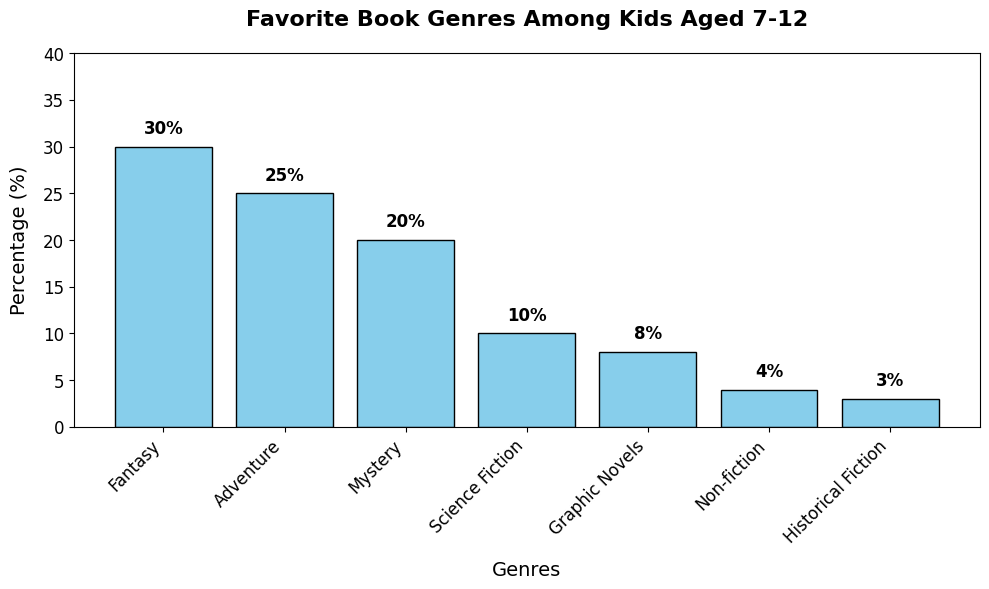What's the most popular book genre among kids aged 7-12? The tallest bar represents the most popular book genre. In the figure, the tallest bar is labeled "Fantasy".
Answer: Fantasy Which genre has a higher percentage, Adventure or Mystery? By comparing the heights of the bars for Adventure and Mystery, you can see that Adventure is taller. The percentages listed show Adventure at 25% and Mystery at 20%.
Answer: Adventure What is the combined percentage of kids who prefer Fantasy and Adventure genres? First, find the percentages for Fantasy (30%) and Adventure (25%). Then, add them together: 30% + 25% = 55%.
Answer: 55% How much more popular is Science Fiction compared to Non-fiction? Find the percentages for Science Fiction (10%) and Non-fiction (4%). Subtract Non-fiction from Science Fiction: 10% - 4% = 6%.
Answer: 6% Which genre is the least popular among kids aged 7-12? The shortest bar represents the least popular book genre. In the figure, the shortest bar is labeled "Historical Fiction".
Answer: Historical Fiction Is the percentage of kids who like Graphic Novels greater than those who like Non-fiction? By comparing the heights of the bars for Graphic Novels and Non-fiction, you can see that Graphic Novels are taller. The listed percentages are 8% for Graphic Novels and 4% for Non-fiction.
Answer: Yes What is the difference in popularity between the most popular and the least popular genre? Calculate the difference by subtracting the percentage of the least popular genre (Historical Fiction, 3%) from the most popular genre (Fantasy, 30%): 30% - 3% = 27%.
Answer: 27% What is the average percentage of kids who prefer Mystery and Science Fiction genres? First, find the percentages for Mystery (20%) and Science Fiction (10%). Then, add them up and divide by 2: (20% + 10%) / 2 = 15%.
Answer: 15% By how much do kids prefer Fantasy over Graphic Novels? Find the percentages for Fantasy (30%) and Graphic Novels (8%). Subtract the percentage of Graphic Novels from Fantasy: 30% - 8% = 22%.
Answer: 22% What are the genres with a percentage of 10% or less? Check the bars with percentages 10% or less: Science Fiction (10%), Graphic Novels (8%), Non-fiction (4%), and Historical Fiction (3%).
Answer: Science Fiction, Graphic Novels, Non-fiction, Historical Fiction 